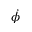Convert formula to latex. <formula><loc_0><loc_0><loc_500><loc_500>\dot { \phi }</formula> 